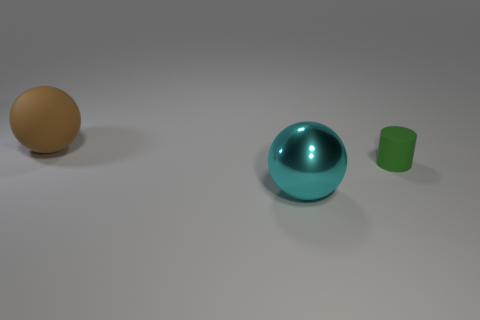How many cubes are either big cyan metal objects or tiny green rubber objects?
Offer a terse response. 0. There is another shiny sphere that is the same size as the brown ball; what color is it?
Provide a succinct answer. Cyan. Is there any other thing that is the same shape as the tiny rubber thing?
Your answer should be compact. No. The other object that is the same shape as the cyan shiny thing is what color?
Provide a succinct answer. Brown. What number of objects are small gray shiny cylinders or large things left of the shiny sphere?
Ensure brevity in your answer.  1. Is the number of metal spheres that are behind the big metal ball less than the number of large objects?
Give a very brief answer. Yes. There is a sphere that is on the left side of the sphere that is in front of the sphere that is left of the big cyan sphere; how big is it?
Offer a terse response. Large. There is a object that is both in front of the large brown rubber ball and left of the small green object; what is its color?
Give a very brief answer. Cyan. How many purple spheres are there?
Offer a terse response. 0. Is there anything else that has the same size as the green cylinder?
Keep it short and to the point. No. 